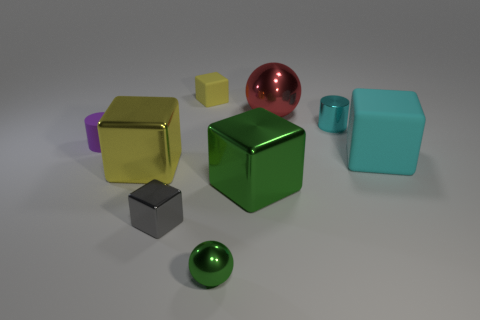Subtract all big yellow blocks. How many blocks are left? 4 Subtract all cyan blocks. How many blocks are left? 4 Subtract 2 spheres. How many spheres are left? 0 Subtract all cubes. How many objects are left? 4 Subtract all blue cylinders. Subtract all blue balls. How many cylinders are left? 2 Subtract all purple balls. How many purple cubes are left? 0 Subtract 1 cyan cylinders. How many objects are left? 8 Subtract all purple matte blocks. Subtract all red spheres. How many objects are left? 8 Add 5 big yellow cubes. How many big yellow cubes are left? 6 Add 8 tiny yellow shiny balls. How many tiny yellow shiny balls exist? 8 